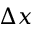<formula> <loc_0><loc_0><loc_500><loc_500>\Delta x</formula> 